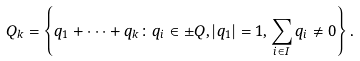Convert formula to latex. <formula><loc_0><loc_0><loc_500><loc_500>Q _ { k } = \left \{ q _ { 1 } + \dots + q _ { k } \colon q _ { i } \in \pm Q , | q _ { 1 } | = 1 , \sum _ { i \in I } q _ { i } \neq 0 \right \} .</formula> 